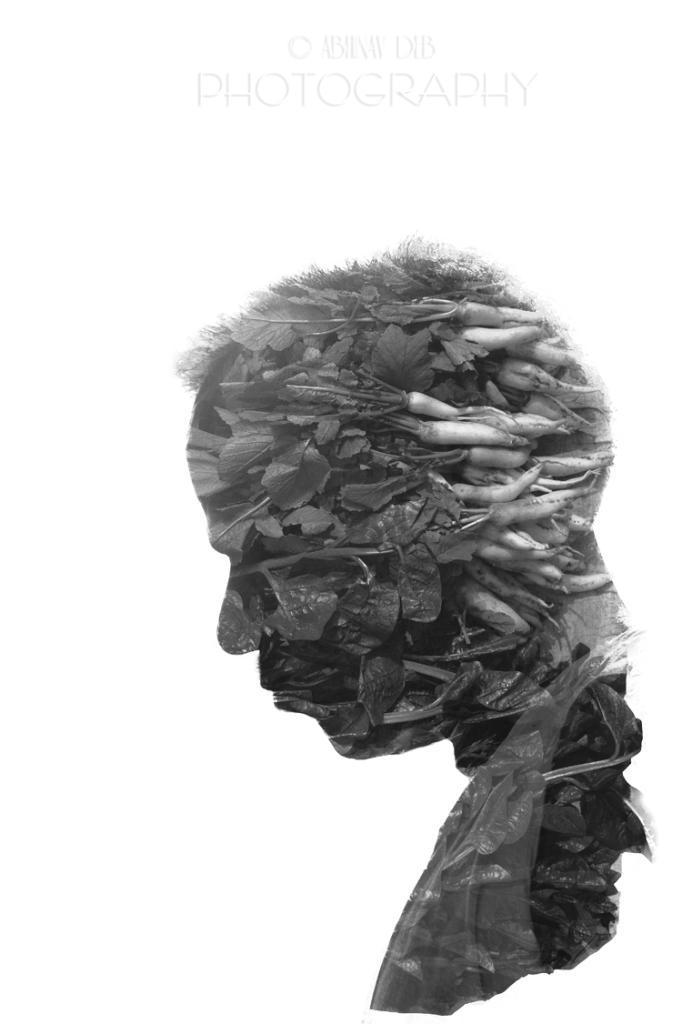How would you summarize this image in a sentence or two? This is a photography of a man using vegetables and on the top of the image, we can see a text written. 